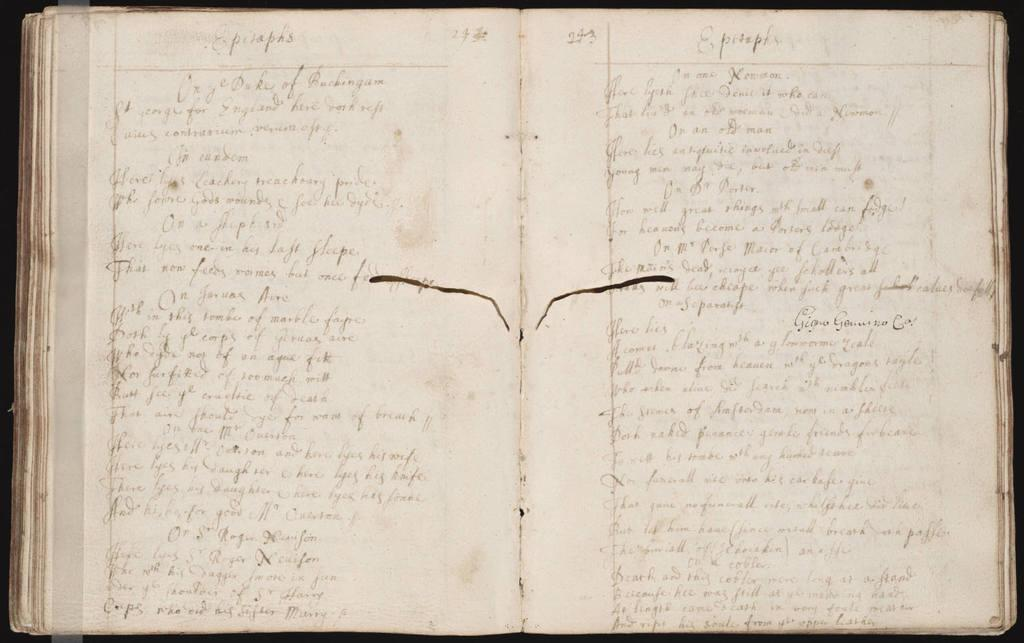<image>
Render a clear and concise summary of the photo. A book with writings under the heading Epitaphs. 